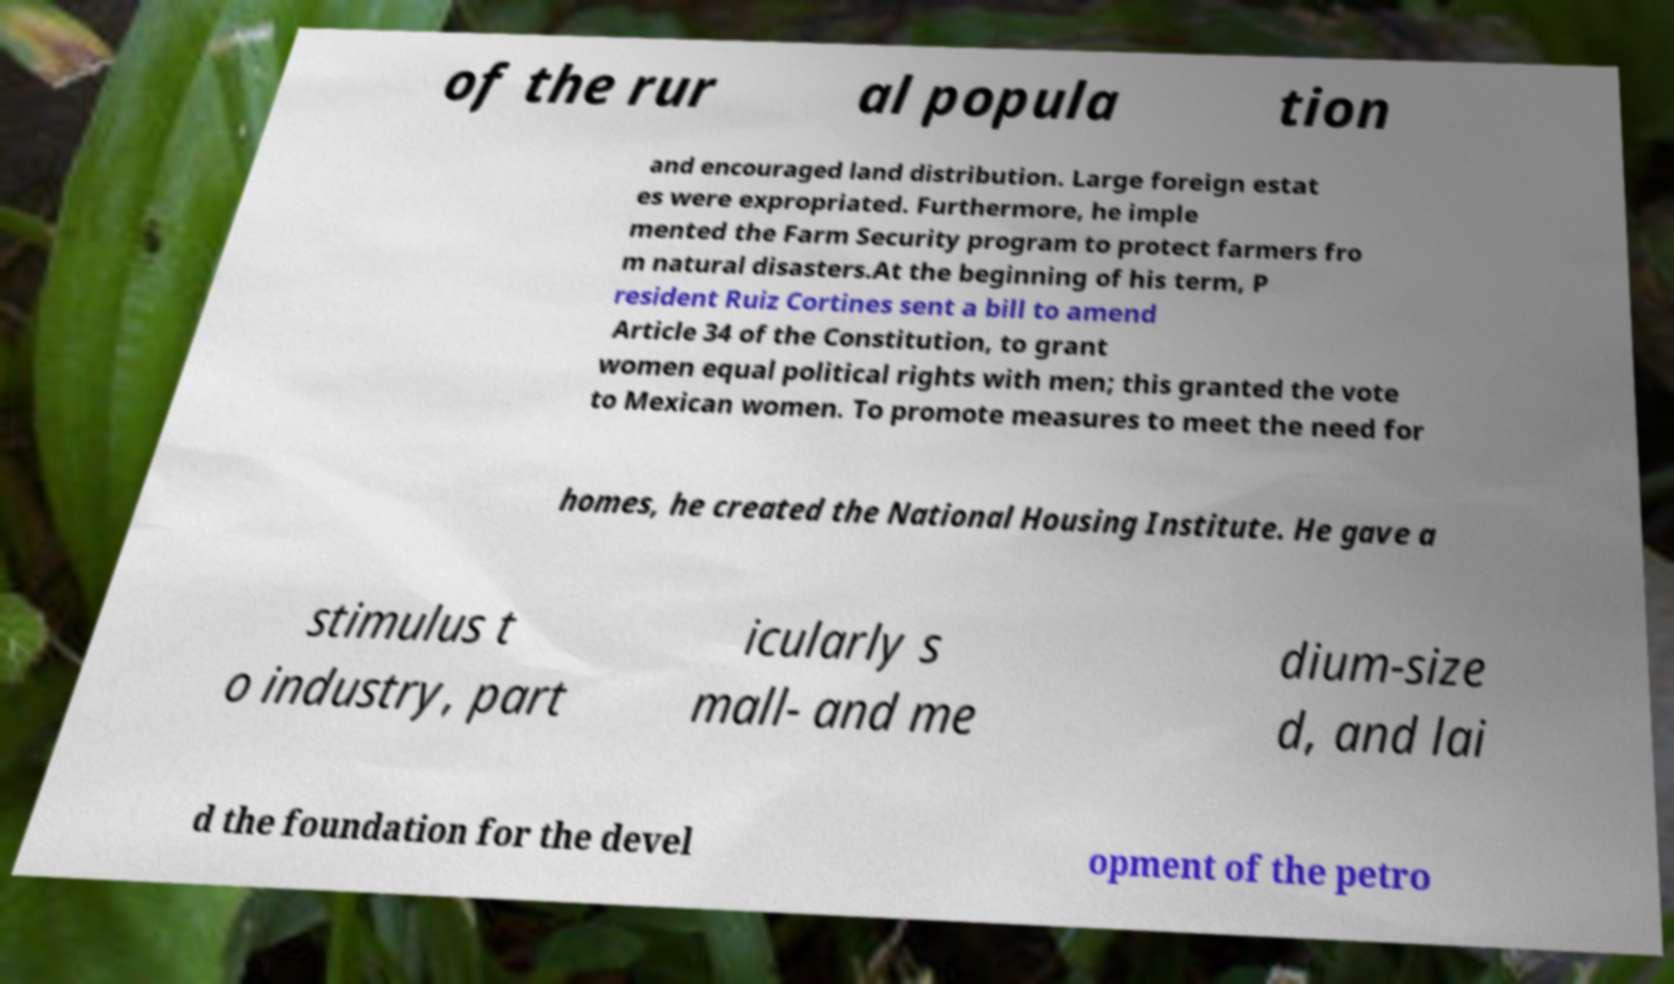Can you read and provide the text displayed in the image?This photo seems to have some interesting text. Can you extract and type it out for me? of the rur al popula tion and encouraged land distribution. Large foreign estat es were expropriated. Furthermore, he imple mented the Farm Security program to protect farmers fro m natural disasters.At the beginning of his term, P resident Ruiz Cortines sent a bill to amend Article 34 of the Constitution, to grant women equal political rights with men; this granted the vote to Mexican women. To promote measures to meet the need for homes, he created the National Housing Institute. He gave a stimulus t o industry, part icularly s mall- and me dium-size d, and lai d the foundation for the devel opment of the petro 